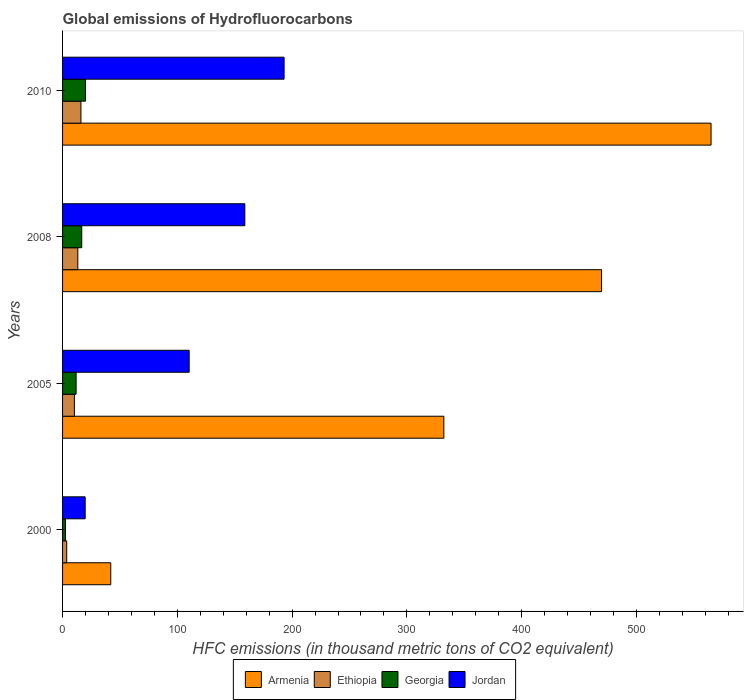How many different coloured bars are there?
Ensure brevity in your answer.  4. Are the number of bars per tick equal to the number of legend labels?
Ensure brevity in your answer.  Yes. Are the number of bars on each tick of the Y-axis equal?
Keep it short and to the point. Yes. How many bars are there on the 1st tick from the top?
Your response must be concise. 4. How many bars are there on the 3rd tick from the bottom?
Keep it short and to the point. 4. In how many cases, is the number of bars for a given year not equal to the number of legend labels?
Keep it short and to the point. 0. What is the global emissions of Hydrofluorocarbons in Armenia in 2010?
Keep it short and to the point. 565. Across all years, what is the maximum global emissions of Hydrofluorocarbons in Georgia?
Offer a very short reply. 20. Across all years, what is the minimum global emissions of Hydrofluorocarbons in Jordan?
Keep it short and to the point. 19.7. In which year was the global emissions of Hydrofluorocarbons in Jordan maximum?
Make the answer very short. 2010. What is the total global emissions of Hydrofluorocarbons in Jordan in the graph?
Keep it short and to the point. 481.8. What is the difference between the global emissions of Hydrofluorocarbons in Armenia in 2008 and that in 2010?
Your answer should be very brief. -95.4. What is the difference between the global emissions of Hydrofluorocarbons in Ethiopia in 2010 and the global emissions of Hydrofluorocarbons in Jordan in 2008?
Your response must be concise. -142.8. What is the average global emissions of Hydrofluorocarbons in Jordan per year?
Provide a short and direct response. 120.45. In the year 2005, what is the difference between the global emissions of Hydrofluorocarbons in Ethiopia and global emissions of Hydrofluorocarbons in Jordan?
Your answer should be very brief. -100. In how many years, is the global emissions of Hydrofluorocarbons in Jordan greater than 140 thousand metric tons?
Your answer should be compact. 2. What is the ratio of the global emissions of Hydrofluorocarbons in Ethiopia in 2005 to that in 2010?
Give a very brief answer. 0.64. What is the difference between the highest and the second highest global emissions of Hydrofluorocarbons in Ethiopia?
Provide a succinct answer. 2.7. What is the difference between the highest and the lowest global emissions of Hydrofluorocarbons in Armenia?
Ensure brevity in your answer.  523. In how many years, is the global emissions of Hydrofluorocarbons in Georgia greater than the average global emissions of Hydrofluorocarbons in Georgia taken over all years?
Your response must be concise. 2. Is it the case that in every year, the sum of the global emissions of Hydrofluorocarbons in Georgia and global emissions of Hydrofluorocarbons in Jordan is greater than the sum of global emissions of Hydrofluorocarbons in Armenia and global emissions of Hydrofluorocarbons in Ethiopia?
Offer a very short reply. No. What does the 4th bar from the top in 2008 represents?
Make the answer very short. Armenia. What does the 1st bar from the bottom in 2000 represents?
Make the answer very short. Armenia. How many bars are there?
Offer a terse response. 16. Are all the bars in the graph horizontal?
Your response must be concise. Yes. How many years are there in the graph?
Keep it short and to the point. 4. What is the difference between two consecutive major ticks on the X-axis?
Your response must be concise. 100. Does the graph contain grids?
Ensure brevity in your answer.  No. How many legend labels are there?
Ensure brevity in your answer.  4. How are the legend labels stacked?
Offer a very short reply. Horizontal. What is the title of the graph?
Your response must be concise. Global emissions of Hydrofluorocarbons. Does "Ecuador" appear as one of the legend labels in the graph?
Offer a terse response. No. What is the label or title of the X-axis?
Provide a succinct answer. HFC emissions (in thousand metric tons of CO2 equivalent). What is the HFC emissions (in thousand metric tons of CO2 equivalent) in Ethiopia in 2000?
Ensure brevity in your answer.  3.6. What is the HFC emissions (in thousand metric tons of CO2 equivalent) of Jordan in 2000?
Offer a very short reply. 19.7. What is the HFC emissions (in thousand metric tons of CO2 equivalent) of Armenia in 2005?
Offer a terse response. 332.2. What is the HFC emissions (in thousand metric tons of CO2 equivalent) of Georgia in 2005?
Offer a very short reply. 11.8. What is the HFC emissions (in thousand metric tons of CO2 equivalent) in Jordan in 2005?
Your answer should be very brief. 110.3. What is the HFC emissions (in thousand metric tons of CO2 equivalent) in Armenia in 2008?
Make the answer very short. 469.6. What is the HFC emissions (in thousand metric tons of CO2 equivalent) of Georgia in 2008?
Keep it short and to the point. 16.7. What is the HFC emissions (in thousand metric tons of CO2 equivalent) in Jordan in 2008?
Give a very brief answer. 158.8. What is the HFC emissions (in thousand metric tons of CO2 equivalent) of Armenia in 2010?
Your response must be concise. 565. What is the HFC emissions (in thousand metric tons of CO2 equivalent) of Jordan in 2010?
Keep it short and to the point. 193. Across all years, what is the maximum HFC emissions (in thousand metric tons of CO2 equivalent) of Armenia?
Provide a short and direct response. 565. Across all years, what is the maximum HFC emissions (in thousand metric tons of CO2 equivalent) of Georgia?
Ensure brevity in your answer.  20. Across all years, what is the maximum HFC emissions (in thousand metric tons of CO2 equivalent) in Jordan?
Provide a succinct answer. 193. What is the total HFC emissions (in thousand metric tons of CO2 equivalent) in Armenia in the graph?
Your answer should be very brief. 1408.8. What is the total HFC emissions (in thousand metric tons of CO2 equivalent) of Ethiopia in the graph?
Your answer should be compact. 43.2. What is the total HFC emissions (in thousand metric tons of CO2 equivalent) of Jordan in the graph?
Provide a succinct answer. 481.8. What is the difference between the HFC emissions (in thousand metric tons of CO2 equivalent) of Armenia in 2000 and that in 2005?
Your answer should be compact. -290.2. What is the difference between the HFC emissions (in thousand metric tons of CO2 equivalent) of Ethiopia in 2000 and that in 2005?
Your answer should be compact. -6.7. What is the difference between the HFC emissions (in thousand metric tons of CO2 equivalent) of Georgia in 2000 and that in 2005?
Give a very brief answer. -9.3. What is the difference between the HFC emissions (in thousand metric tons of CO2 equivalent) of Jordan in 2000 and that in 2005?
Keep it short and to the point. -90.6. What is the difference between the HFC emissions (in thousand metric tons of CO2 equivalent) in Armenia in 2000 and that in 2008?
Offer a very short reply. -427.6. What is the difference between the HFC emissions (in thousand metric tons of CO2 equivalent) in Ethiopia in 2000 and that in 2008?
Provide a short and direct response. -9.7. What is the difference between the HFC emissions (in thousand metric tons of CO2 equivalent) of Jordan in 2000 and that in 2008?
Provide a succinct answer. -139.1. What is the difference between the HFC emissions (in thousand metric tons of CO2 equivalent) in Armenia in 2000 and that in 2010?
Your response must be concise. -523. What is the difference between the HFC emissions (in thousand metric tons of CO2 equivalent) of Ethiopia in 2000 and that in 2010?
Provide a succinct answer. -12.4. What is the difference between the HFC emissions (in thousand metric tons of CO2 equivalent) in Georgia in 2000 and that in 2010?
Your answer should be compact. -17.5. What is the difference between the HFC emissions (in thousand metric tons of CO2 equivalent) of Jordan in 2000 and that in 2010?
Provide a succinct answer. -173.3. What is the difference between the HFC emissions (in thousand metric tons of CO2 equivalent) of Armenia in 2005 and that in 2008?
Ensure brevity in your answer.  -137.4. What is the difference between the HFC emissions (in thousand metric tons of CO2 equivalent) of Jordan in 2005 and that in 2008?
Offer a terse response. -48.5. What is the difference between the HFC emissions (in thousand metric tons of CO2 equivalent) in Armenia in 2005 and that in 2010?
Provide a succinct answer. -232.8. What is the difference between the HFC emissions (in thousand metric tons of CO2 equivalent) of Jordan in 2005 and that in 2010?
Offer a terse response. -82.7. What is the difference between the HFC emissions (in thousand metric tons of CO2 equivalent) in Armenia in 2008 and that in 2010?
Keep it short and to the point. -95.4. What is the difference between the HFC emissions (in thousand metric tons of CO2 equivalent) in Ethiopia in 2008 and that in 2010?
Provide a short and direct response. -2.7. What is the difference between the HFC emissions (in thousand metric tons of CO2 equivalent) of Georgia in 2008 and that in 2010?
Give a very brief answer. -3.3. What is the difference between the HFC emissions (in thousand metric tons of CO2 equivalent) in Jordan in 2008 and that in 2010?
Provide a short and direct response. -34.2. What is the difference between the HFC emissions (in thousand metric tons of CO2 equivalent) in Armenia in 2000 and the HFC emissions (in thousand metric tons of CO2 equivalent) in Ethiopia in 2005?
Your answer should be compact. 31.7. What is the difference between the HFC emissions (in thousand metric tons of CO2 equivalent) of Armenia in 2000 and the HFC emissions (in thousand metric tons of CO2 equivalent) of Georgia in 2005?
Your answer should be compact. 30.2. What is the difference between the HFC emissions (in thousand metric tons of CO2 equivalent) of Armenia in 2000 and the HFC emissions (in thousand metric tons of CO2 equivalent) of Jordan in 2005?
Ensure brevity in your answer.  -68.3. What is the difference between the HFC emissions (in thousand metric tons of CO2 equivalent) of Ethiopia in 2000 and the HFC emissions (in thousand metric tons of CO2 equivalent) of Jordan in 2005?
Ensure brevity in your answer.  -106.7. What is the difference between the HFC emissions (in thousand metric tons of CO2 equivalent) in Georgia in 2000 and the HFC emissions (in thousand metric tons of CO2 equivalent) in Jordan in 2005?
Keep it short and to the point. -107.8. What is the difference between the HFC emissions (in thousand metric tons of CO2 equivalent) in Armenia in 2000 and the HFC emissions (in thousand metric tons of CO2 equivalent) in Ethiopia in 2008?
Give a very brief answer. 28.7. What is the difference between the HFC emissions (in thousand metric tons of CO2 equivalent) in Armenia in 2000 and the HFC emissions (in thousand metric tons of CO2 equivalent) in Georgia in 2008?
Offer a terse response. 25.3. What is the difference between the HFC emissions (in thousand metric tons of CO2 equivalent) in Armenia in 2000 and the HFC emissions (in thousand metric tons of CO2 equivalent) in Jordan in 2008?
Your response must be concise. -116.8. What is the difference between the HFC emissions (in thousand metric tons of CO2 equivalent) in Ethiopia in 2000 and the HFC emissions (in thousand metric tons of CO2 equivalent) in Jordan in 2008?
Give a very brief answer. -155.2. What is the difference between the HFC emissions (in thousand metric tons of CO2 equivalent) in Georgia in 2000 and the HFC emissions (in thousand metric tons of CO2 equivalent) in Jordan in 2008?
Your answer should be compact. -156.3. What is the difference between the HFC emissions (in thousand metric tons of CO2 equivalent) in Armenia in 2000 and the HFC emissions (in thousand metric tons of CO2 equivalent) in Georgia in 2010?
Give a very brief answer. 22. What is the difference between the HFC emissions (in thousand metric tons of CO2 equivalent) of Armenia in 2000 and the HFC emissions (in thousand metric tons of CO2 equivalent) of Jordan in 2010?
Your answer should be very brief. -151. What is the difference between the HFC emissions (in thousand metric tons of CO2 equivalent) of Ethiopia in 2000 and the HFC emissions (in thousand metric tons of CO2 equivalent) of Georgia in 2010?
Your answer should be very brief. -16.4. What is the difference between the HFC emissions (in thousand metric tons of CO2 equivalent) in Ethiopia in 2000 and the HFC emissions (in thousand metric tons of CO2 equivalent) in Jordan in 2010?
Give a very brief answer. -189.4. What is the difference between the HFC emissions (in thousand metric tons of CO2 equivalent) in Georgia in 2000 and the HFC emissions (in thousand metric tons of CO2 equivalent) in Jordan in 2010?
Offer a terse response. -190.5. What is the difference between the HFC emissions (in thousand metric tons of CO2 equivalent) of Armenia in 2005 and the HFC emissions (in thousand metric tons of CO2 equivalent) of Ethiopia in 2008?
Your answer should be compact. 318.9. What is the difference between the HFC emissions (in thousand metric tons of CO2 equivalent) of Armenia in 2005 and the HFC emissions (in thousand metric tons of CO2 equivalent) of Georgia in 2008?
Make the answer very short. 315.5. What is the difference between the HFC emissions (in thousand metric tons of CO2 equivalent) in Armenia in 2005 and the HFC emissions (in thousand metric tons of CO2 equivalent) in Jordan in 2008?
Ensure brevity in your answer.  173.4. What is the difference between the HFC emissions (in thousand metric tons of CO2 equivalent) of Ethiopia in 2005 and the HFC emissions (in thousand metric tons of CO2 equivalent) of Georgia in 2008?
Your answer should be very brief. -6.4. What is the difference between the HFC emissions (in thousand metric tons of CO2 equivalent) of Ethiopia in 2005 and the HFC emissions (in thousand metric tons of CO2 equivalent) of Jordan in 2008?
Give a very brief answer. -148.5. What is the difference between the HFC emissions (in thousand metric tons of CO2 equivalent) in Georgia in 2005 and the HFC emissions (in thousand metric tons of CO2 equivalent) in Jordan in 2008?
Make the answer very short. -147. What is the difference between the HFC emissions (in thousand metric tons of CO2 equivalent) in Armenia in 2005 and the HFC emissions (in thousand metric tons of CO2 equivalent) in Ethiopia in 2010?
Your answer should be very brief. 316.2. What is the difference between the HFC emissions (in thousand metric tons of CO2 equivalent) in Armenia in 2005 and the HFC emissions (in thousand metric tons of CO2 equivalent) in Georgia in 2010?
Give a very brief answer. 312.2. What is the difference between the HFC emissions (in thousand metric tons of CO2 equivalent) of Armenia in 2005 and the HFC emissions (in thousand metric tons of CO2 equivalent) of Jordan in 2010?
Keep it short and to the point. 139.2. What is the difference between the HFC emissions (in thousand metric tons of CO2 equivalent) in Ethiopia in 2005 and the HFC emissions (in thousand metric tons of CO2 equivalent) in Georgia in 2010?
Your answer should be compact. -9.7. What is the difference between the HFC emissions (in thousand metric tons of CO2 equivalent) in Ethiopia in 2005 and the HFC emissions (in thousand metric tons of CO2 equivalent) in Jordan in 2010?
Offer a terse response. -182.7. What is the difference between the HFC emissions (in thousand metric tons of CO2 equivalent) of Georgia in 2005 and the HFC emissions (in thousand metric tons of CO2 equivalent) of Jordan in 2010?
Your answer should be compact. -181.2. What is the difference between the HFC emissions (in thousand metric tons of CO2 equivalent) in Armenia in 2008 and the HFC emissions (in thousand metric tons of CO2 equivalent) in Ethiopia in 2010?
Ensure brevity in your answer.  453.6. What is the difference between the HFC emissions (in thousand metric tons of CO2 equivalent) in Armenia in 2008 and the HFC emissions (in thousand metric tons of CO2 equivalent) in Georgia in 2010?
Ensure brevity in your answer.  449.6. What is the difference between the HFC emissions (in thousand metric tons of CO2 equivalent) of Armenia in 2008 and the HFC emissions (in thousand metric tons of CO2 equivalent) of Jordan in 2010?
Provide a short and direct response. 276.6. What is the difference between the HFC emissions (in thousand metric tons of CO2 equivalent) in Ethiopia in 2008 and the HFC emissions (in thousand metric tons of CO2 equivalent) in Georgia in 2010?
Your response must be concise. -6.7. What is the difference between the HFC emissions (in thousand metric tons of CO2 equivalent) in Ethiopia in 2008 and the HFC emissions (in thousand metric tons of CO2 equivalent) in Jordan in 2010?
Your answer should be very brief. -179.7. What is the difference between the HFC emissions (in thousand metric tons of CO2 equivalent) of Georgia in 2008 and the HFC emissions (in thousand metric tons of CO2 equivalent) of Jordan in 2010?
Provide a short and direct response. -176.3. What is the average HFC emissions (in thousand metric tons of CO2 equivalent) of Armenia per year?
Give a very brief answer. 352.2. What is the average HFC emissions (in thousand metric tons of CO2 equivalent) in Ethiopia per year?
Ensure brevity in your answer.  10.8. What is the average HFC emissions (in thousand metric tons of CO2 equivalent) of Georgia per year?
Your response must be concise. 12.75. What is the average HFC emissions (in thousand metric tons of CO2 equivalent) in Jordan per year?
Give a very brief answer. 120.45. In the year 2000, what is the difference between the HFC emissions (in thousand metric tons of CO2 equivalent) of Armenia and HFC emissions (in thousand metric tons of CO2 equivalent) of Ethiopia?
Offer a very short reply. 38.4. In the year 2000, what is the difference between the HFC emissions (in thousand metric tons of CO2 equivalent) in Armenia and HFC emissions (in thousand metric tons of CO2 equivalent) in Georgia?
Your answer should be very brief. 39.5. In the year 2000, what is the difference between the HFC emissions (in thousand metric tons of CO2 equivalent) in Armenia and HFC emissions (in thousand metric tons of CO2 equivalent) in Jordan?
Your response must be concise. 22.3. In the year 2000, what is the difference between the HFC emissions (in thousand metric tons of CO2 equivalent) in Ethiopia and HFC emissions (in thousand metric tons of CO2 equivalent) in Georgia?
Offer a very short reply. 1.1. In the year 2000, what is the difference between the HFC emissions (in thousand metric tons of CO2 equivalent) of Ethiopia and HFC emissions (in thousand metric tons of CO2 equivalent) of Jordan?
Make the answer very short. -16.1. In the year 2000, what is the difference between the HFC emissions (in thousand metric tons of CO2 equivalent) in Georgia and HFC emissions (in thousand metric tons of CO2 equivalent) in Jordan?
Give a very brief answer. -17.2. In the year 2005, what is the difference between the HFC emissions (in thousand metric tons of CO2 equivalent) in Armenia and HFC emissions (in thousand metric tons of CO2 equivalent) in Ethiopia?
Provide a short and direct response. 321.9. In the year 2005, what is the difference between the HFC emissions (in thousand metric tons of CO2 equivalent) in Armenia and HFC emissions (in thousand metric tons of CO2 equivalent) in Georgia?
Offer a terse response. 320.4. In the year 2005, what is the difference between the HFC emissions (in thousand metric tons of CO2 equivalent) in Armenia and HFC emissions (in thousand metric tons of CO2 equivalent) in Jordan?
Offer a terse response. 221.9. In the year 2005, what is the difference between the HFC emissions (in thousand metric tons of CO2 equivalent) of Ethiopia and HFC emissions (in thousand metric tons of CO2 equivalent) of Georgia?
Your answer should be compact. -1.5. In the year 2005, what is the difference between the HFC emissions (in thousand metric tons of CO2 equivalent) of Ethiopia and HFC emissions (in thousand metric tons of CO2 equivalent) of Jordan?
Offer a very short reply. -100. In the year 2005, what is the difference between the HFC emissions (in thousand metric tons of CO2 equivalent) of Georgia and HFC emissions (in thousand metric tons of CO2 equivalent) of Jordan?
Provide a short and direct response. -98.5. In the year 2008, what is the difference between the HFC emissions (in thousand metric tons of CO2 equivalent) in Armenia and HFC emissions (in thousand metric tons of CO2 equivalent) in Ethiopia?
Provide a short and direct response. 456.3. In the year 2008, what is the difference between the HFC emissions (in thousand metric tons of CO2 equivalent) of Armenia and HFC emissions (in thousand metric tons of CO2 equivalent) of Georgia?
Make the answer very short. 452.9. In the year 2008, what is the difference between the HFC emissions (in thousand metric tons of CO2 equivalent) in Armenia and HFC emissions (in thousand metric tons of CO2 equivalent) in Jordan?
Your response must be concise. 310.8. In the year 2008, what is the difference between the HFC emissions (in thousand metric tons of CO2 equivalent) of Ethiopia and HFC emissions (in thousand metric tons of CO2 equivalent) of Jordan?
Make the answer very short. -145.5. In the year 2008, what is the difference between the HFC emissions (in thousand metric tons of CO2 equivalent) in Georgia and HFC emissions (in thousand metric tons of CO2 equivalent) in Jordan?
Provide a short and direct response. -142.1. In the year 2010, what is the difference between the HFC emissions (in thousand metric tons of CO2 equivalent) in Armenia and HFC emissions (in thousand metric tons of CO2 equivalent) in Ethiopia?
Make the answer very short. 549. In the year 2010, what is the difference between the HFC emissions (in thousand metric tons of CO2 equivalent) in Armenia and HFC emissions (in thousand metric tons of CO2 equivalent) in Georgia?
Offer a very short reply. 545. In the year 2010, what is the difference between the HFC emissions (in thousand metric tons of CO2 equivalent) of Armenia and HFC emissions (in thousand metric tons of CO2 equivalent) of Jordan?
Provide a succinct answer. 372. In the year 2010, what is the difference between the HFC emissions (in thousand metric tons of CO2 equivalent) in Ethiopia and HFC emissions (in thousand metric tons of CO2 equivalent) in Jordan?
Make the answer very short. -177. In the year 2010, what is the difference between the HFC emissions (in thousand metric tons of CO2 equivalent) in Georgia and HFC emissions (in thousand metric tons of CO2 equivalent) in Jordan?
Keep it short and to the point. -173. What is the ratio of the HFC emissions (in thousand metric tons of CO2 equivalent) of Armenia in 2000 to that in 2005?
Your answer should be very brief. 0.13. What is the ratio of the HFC emissions (in thousand metric tons of CO2 equivalent) of Ethiopia in 2000 to that in 2005?
Give a very brief answer. 0.35. What is the ratio of the HFC emissions (in thousand metric tons of CO2 equivalent) of Georgia in 2000 to that in 2005?
Offer a very short reply. 0.21. What is the ratio of the HFC emissions (in thousand metric tons of CO2 equivalent) in Jordan in 2000 to that in 2005?
Provide a short and direct response. 0.18. What is the ratio of the HFC emissions (in thousand metric tons of CO2 equivalent) in Armenia in 2000 to that in 2008?
Keep it short and to the point. 0.09. What is the ratio of the HFC emissions (in thousand metric tons of CO2 equivalent) of Ethiopia in 2000 to that in 2008?
Keep it short and to the point. 0.27. What is the ratio of the HFC emissions (in thousand metric tons of CO2 equivalent) in Georgia in 2000 to that in 2008?
Offer a terse response. 0.15. What is the ratio of the HFC emissions (in thousand metric tons of CO2 equivalent) in Jordan in 2000 to that in 2008?
Offer a very short reply. 0.12. What is the ratio of the HFC emissions (in thousand metric tons of CO2 equivalent) in Armenia in 2000 to that in 2010?
Provide a short and direct response. 0.07. What is the ratio of the HFC emissions (in thousand metric tons of CO2 equivalent) of Ethiopia in 2000 to that in 2010?
Make the answer very short. 0.23. What is the ratio of the HFC emissions (in thousand metric tons of CO2 equivalent) in Georgia in 2000 to that in 2010?
Give a very brief answer. 0.12. What is the ratio of the HFC emissions (in thousand metric tons of CO2 equivalent) of Jordan in 2000 to that in 2010?
Keep it short and to the point. 0.1. What is the ratio of the HFC emissions (in thousand metric tons of CO2 equivalent) in Armenia in 2005 to that in 2008?
Your response must be concise. 0.71. What is the ratio of the HFC emissions (in thousand metric tons of CO2 equivalent) in Ethiopia in 2005 to that in 2008?
Offer a very short reply. 0.77. What is the ratio of the HFC emissions (in thousand metric tons of CO2 equivalent) of Georgia in 2005 to that in 2008?
Offer a very short reply. 0.71. What is the ratio of the HFC emissions (in thousand metric tons of CO2 equivalent) of Jordan in 2005 to that in 2008?
Your answer should be very brief. 0.69. What is the ratio of the HFC emissions (in thousand metric tons of CO2 equivalent) of Armenia in 2005 to that in 2010?
Your response must be concise. 0.59. What is the ratio of the HFC emissions (in thousand metric tons of CO2 equivalent) of Ethiopia in 2005 to that in 2010?
Make the answer very short. 0.64. What is the ratio of the HFC emissions (in thousand metric tons of CO2 equivalent) in Georgia in 2005 to that in 2010?
Give a very brief answer. 0.59. What is the ratio of the HFC emissions (in thousand metric tons of CO2 equivalent) in Jordan in 2005 to that in 2010?
Ensure brevity in your answer.  0.57. What is the ratio of the HFC emissions (in thousand metric tons of CO2 equivalent) in Armenia in 2008 to that in 2010?
Provide a short and direct response. 0.83. What is the ratio of the HFC emissions (in thousand metric tons of CO2 equivalent) of Ethiopia in 2008 to that in 2010?
Keep it short and to the point. 0.83. What is the ratio of the HFC emissions (in thousand metric tons of CO2 equivalent) of Georgia in 2008 to that in 2010?
Offer a terse response. 0.83. What is the ratio of the HFC emissions (in thousand metric tons of CO2 equivalent) of Jordan in 2008 to that in 2010?
Provide a succinct answer. 0.82. What is the difference between the highest and the second highest HFC emissions (in thousand metric tons of CO2 equivalent) of Armenia?
Provide a succinct answer. 95.4. What is the difference between the highest and the second highest HFC emissions (in thousand metric tons of CO2 equivalent) in Georgia?
Your response must be concise. 3.3. What is the difference between the highest and the second highest HFC emissions (in thousand metric tons of CO2 equivalent) of Jordan?
Your response must be concise. 34.2. What is the difference between the highest and the lowest HFC emissions (in thousand metric tons of CO2 equivalent) in Armenia?
Keep it short and to the point. 523. What is the difference between the highest and the lowest HFC emissions (in thousand metric tons of CO2 equivalent) in Jordan?
Provide a short and direct response. 173.3. 